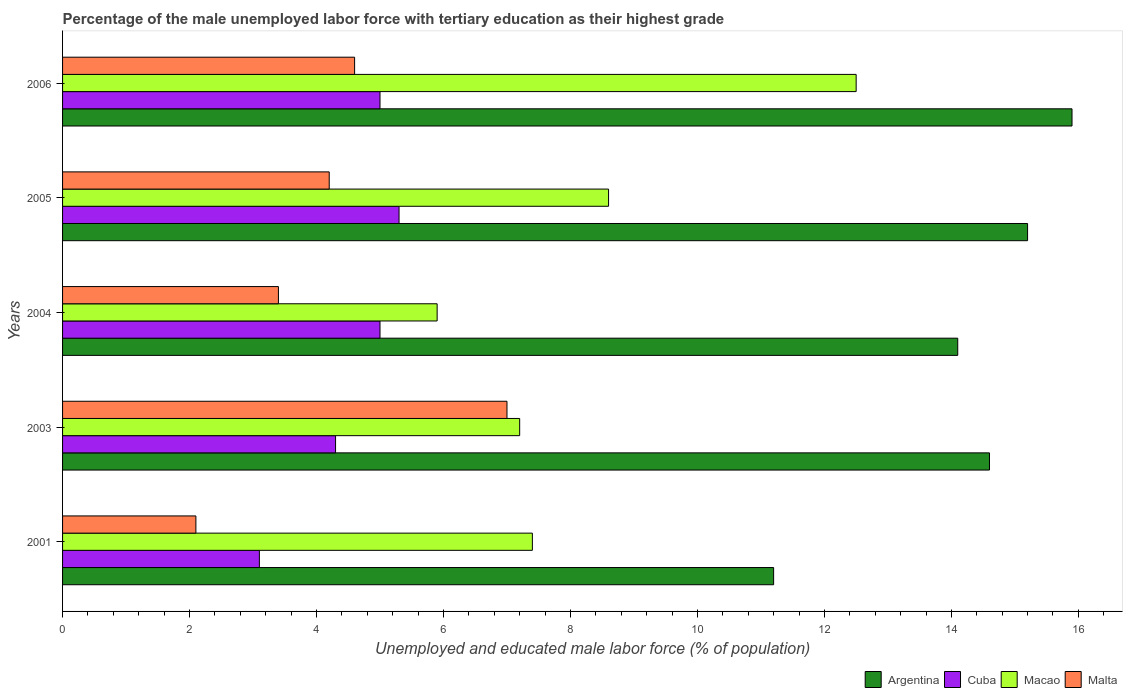How many different coloured bars are there?
Provide a succinct answer. 4. How many groups of bars are there?
Your answer should be very brief. 5. Are the number of bars per tick equal to the number of legend labels?
Make the answer very short. Yes. How many bars are there on the 4th tick from the top?
Provide a succinct answer. 4. How many bars are there on the 3rd tick from the bottom?
Give a very brief answer. 4. What is the percentage of the unemployed male labor force with tertiary education in Cuba in 2001?
Your answer should be very brief. 3.1. Across all years, what is the maximum percentage of the unemployed male labor force with tertiary education in Argentina?
Offer a very short reply. 15.9. Across all years, what is the minimum percentage of the unemployed male labor force with tertiary education in Macao?
Offer a very short reply. 5.9. In which year was the percentage of the unemployed male labor force with tertiary education in Argentina minimum?
Make the answer very short. 2001. What is the total percentage of the unemployed male labor force with tertiary education in Argentina in the graph?
Give a very brief answer. 71. What is the difference between the percentage of the unemployed male labor force with tertiary education in Malta in 2005 and that in 2006?
Make the answer very short. -0.4. What is the difference between the percentage of the unemployed male labor force with tertiary education in Cuba in 2006 and the percentage of the unemployed male labor force with tertiary education in Malta in 2003?
Provide a succinct answer. -2. What is the average percentage of the unemployed male labor force with tertiary education in Argentina per year?
Ensure brevity in your answer.  14.2. In the year 2004, what is the difference between the percentage of the unemployed male labor force with tertiary education in Cuba and percentage of the unemployed male labor force with tertiary education in Argentina?
Give a very brief answer. -9.1. What is the ratio of the percentage of the unemployed male labor force with tertiary education in Cuba in 2003 to that in 2006?
Offer a very short reply. 0.86. Is the difference between the percentage of the unemployed male labor force with tertiary education in Cuba in 2003 and 2004 greater than the difference between the percentage of the unemployed male labor force with tertiary education in Argentina in 2003 and 2004?
Ensure brevity in your answer.  No. What is the difference between the highest and the second highest percentage of the unemployed male labor force with tertiary education in Cuba?
Your answer should be compact. 0.3. What is the difference between the highest and the lowest percentage of the unemployed male labor force with tertiary education in Argentina?
Give a very brief answer. 4.7. What does the 3rd bar from the top in 2001 represents?
Offer a terse response. Cuba. What does the 4th bar from the bottom in 2006 represents?
Provide a short and direct response. Malta. How many bars are there?
Offer a very short reply. 20. Are all the bars in the graph horizontal?
Provide a short and direct response. Yes. What is the difference between two consecutive major ticks on the X-axis?
Your answer should be compact. 2. Does the graph contain any zero values?
Give a very brief answer. No. Where does the legend appear in the graph?
Keep it short and to the point. Bottom right. How many legend labels are there?
Your answer should be compact. 4. What is the title of the graph?
Your answer should be very brief. Percentage of the male unemployed labor force with tertiary education as their highest grade. Does "Bhutan" appear as one of the legend labels in the graph?
Offer a very short reply. No. What is the label or title of the X-axis?
Offer a terse response. Unemployed and educated male labor force (% of population). What is the Unemployed and educated male labor force (% of population) of Argentina in 2001?
Offer a terse response. 11.2. What is the Unemployed and educated male labor force (% of population) in Cuba in 2001?
Give a very brief answer. 3.1. What is the Unemployed and educated male labor force (% of population) of Macao in 2001?
Offer a very short reply. 7.4. What is the Unemployed and educated male labor force (% of population) in Malta in 2001?
Give a very brief answer. 2.1. What is the Unemployed and educated male labor force (% of population) in Argentina in 2003?
Your response must be concise. 14.6. What is the Unemployed and educated male labor force (% of population) of Cuba in 2003?
Provide a succinct answer. 4.3. What is the Unemployed and educated male labor force (% of population) in Macao in 2003?
Provide a short and direct response. 7.2. What is the Unemployed and educated male labor force (% of population) in Malta in 2003?
Make the answer very short. 7. What is the Unemployed and educated male labor force (% of population) of Argentina in 2004?
Keep it short and to the point. 14.1. What is the Unemployed and educated male labor force (% of population) in Macao in 2004?
Offer a terse response. 5.9. What is the Unemployed and educated male labor force (% of population) of Malta in 2004?
Your answer should be very brief. 3.4. What is the Unemployed and educated male labor force (% of population) of Argentina in 2005?
Give a very brief answer. 15.2. What is the Unemployed and educated male labor force (% of population) of Cuba in 2005?
Make the answer very short. 5.3. What is the Unemployed and educated male labor force (% of population) in Macao in 2005?
Keep it short and to the point. 8.6. What is the Unemployed and educated male labor force (% of population) of Malta in 2005?
Give a very brief answer. 4.2. What is the Unemployed and educated male labor force (% of population) in Argentina in 2006?
Your answer should be compact. 15.9. What is the Unemployed and educated male labor force (% of population) in Cuba in 2006?
Your answer should be compact. 5. What is the Unemployed and educated male labor force (% of population) of Malta in 2006?
Provide a short and direct response. 4.6. Across all years, what is the maximum Unemployed and educated male labor force (% of population) in Argentina?
Your answer should be compact. 15.9. Across all years, what is the maximum Unemployed and educated male labor force (% of population) of Cuba?
Provide a succinct answer. 5.3. Across all years, what is the maximum Unemployed and educated male labor force (% of population) in Malta?
Give a very brief answer. 7. Across all years, what is the minimum Unemployed and educated male labor force (% of population) in Argentina?
Your response must be concise. 11.2. Across all years, what is the minimum Unemployed and educated male labor force (% of population) in Cuba?
Ensure brevity in your answer.  3.1. Across all years, what is the minimum Unemployed and educated male labor force (% of population) in Macao?
Provide a short and direct response. 5.9. Across all years, what is the minimum Unemployed and educated male labor force (% of population) of Malta?
Offer a very short reply. 2.1. What is the total Unemployed and educated male labor force (% of population) in Argentina in the graph?
Ensure brevity in your answer.  71. What is the total Unemployed and educated male labor force (% of population) of Cuba in the graph?
Make the answer very short. 22.7. What is the total Unemployed and educated male labor force (% of population) in Macao in the graph?
Your answer should be compact. 41.6. What is the total Unemployed and educated male labor force (% of population) in Malta in the graph?
Provide a short and direct response. 21.3. What is the difference between the Unemployed and educated male labor force (% of population) of Cuba in 2001 and that in 2003?
Provide a succinct answer. -1.2. What is the difference between the Unemployed and educated male labor force (% of population) of Macao in 2001 and that in 2003?
Provide a short and direct response. 0.2. What is the difference between the Unemployed and educated male labor force (% of population) of Malta in 2001 and that in 2003?
Make the answer very short. -4.9. What is the difference between the Unemployed and educated male labor force (% of population) in Argentina in 2001 and that in 2004?
Your answer should be compact. -2.9. What is the difference between the Unemployed and educated male labor force (% of population) in Macao in 2001 and that in 2004?
Provide a short and direct response. 1.5. What is the difference between the Unemployed and educated male labor force (% of population) of Malta in 2001 and that in 2004?
Keep it short and to the point. -1.3. What is the difference between the Unemployed and educated male labor force (% of population) of Cuba in 2001 and that in 2005?
Provide a succinct answer. -2.2. What is the difference between the Unemployed and educated male labor force (% of population) of Macao in 2001 and that in 2005?
Ensure brevity in your answer.  -1.2. What is the difference between the Unemployed and educated male labor force (% of population) of Malta in 2001 and that in 2005?
Provide a short and direct response. -2.1. What is the difference between the Unemployed and educated male labor force (% of population) of Cuba in 2001 and that in 2006?
Your response must be concise. -1.9. What is the difference between the Unemployed and educated male labor force (% of population) of Macao in 2001 and that in 2006?
Ensure brevity in your answer.  -5.1. What is the difference between the Unemployed and educated male labor force (% of population) of Argentina in 2003 and that in 2004?
Give a very brief answer. 0.5. What is the difference between the Unemployed and educated male labor force (% of population) in Cuba in 2003 and that in 2004?
Offer a terse response. -0.7. What is the difference between the Unemployed and educated male labor force (% of population) in Macao in 2003 and that in 2005?
Give a very brief answer. -1.4. What is the difference between the Unemployed and educated male labor force (% of population) of Argentina in 2004 and that in 2005?
Make the answer very short. -1.1. What is the difference between the Unemployed and educated male labor force (% of population) in Macao in 2004 and that in 2005?
Give a very brief answer. -2.7. What is the difference between the Unemployed and educated male labor force (% of population) in Malta in 2004 and that in 2005?
Your answer should be very brief. -0.8. What is the difference between the Unemployed and educated male labor force (% of population) in Argentina in 2004 and that in 2006?
Offer a very short reply. -1.8. What is the difference between the Unemployed and educated male labor force (% of population) of Cuba in 2004 and that in 2006?
Give a very brief answer. 0. What is the difference between the Unemployed and educated male labor force (% of population) of Macao in 2004 and that in 2006?
Your answer should be very brief. -6.6. What is the difference between the Unemployed and educated male labor force (% of population) in Cuba in 2005 and that in 2006?
Make the answer very short. 0.3. What is the difference between the Unemployed and educated male labor force (% of population) of Malta in 2005 and that in 2006?
Give a very brief answer. -0.4. What is the difference between the Unemployed and educated male labor force (% of population) in Argentina in 2001 and the Unemployed and educated male labor force (% of population) in Macao in 2003?
Offer a very short reply. 4. What is the difference between the Unemployed and educated male labor force (% of population) in Cuba in 2001 and the Unemployed and educated male labor force (% of population) in Macao in 2003?
Your response must be concise. -4.1. What is the difference between the Unemployed and educated male labor force (% of population) of Cuba in 2001 and the Unemployed and educated male labor force (% of population) of Malta in 2003?
Offer a very short reply. -3.9. What is the difference between the Unemployed and educated male labor force (% of population) of Macao in 2001 and the Unemployed and educated male labor force (% of population) of Malta in 2003?
Keep it short and to the point. 0.4. What is the difference between the Unemployed and educated male labor force (% of population) of Argentina in 2001 and the Unemployed and educated male labor force (% of population) of Cuba in 2004?
Ensure brevity in your answer.  6.2. What is the difference between the Unemployed and educated male labor force (% of population) in Argentina in 2001 and the Unemployed and educated male labor force (% of population) in Macao in 2004?
Make the answer very short. 5.3. What is the difference between the Unemployed and educated male labor force (% of population) of Cuba in 2001 and the Unemployed and educated male labor force (% of population) of Malta in 2004?
Offer a very short reply. -0.3. What is the difference between the Unemployed and educated male labor force (% of population) of Macao in 2001 and the Unemployed and educated male labor force (% of population) of Malta in 2004?
Provide a succinct answer. 4. What is the difference between the Unemployed and educated male labor force (% of population) in Argentina in 2001 and the Unemployed and educated male labor force (% of population) in Malta in 2005?
Give a very brief answer. 7. What is the difference between the Unemployed and educated male labor force (% of population) in Cuba in 2001 and the Unemployed and educated male labor force (% of population) in Macao in 2005?
Offer a terse response. -5.5. What is the difference between the Unemployed and educated male labor force (% of population) in Cuba in 2001 and the Unemployed and educated male labor force (% of population) in Malta in 2005?
Offer a very short reply. -1.1. What is the difference between the Unemployed and educated male labor force (% of population) of Argentina in 2001 and the Unemployed and educated male labor force (% of population) of Macao in 2006?
Offer a very short reply. -1.3. What is the difference between the Unemployed and educated male labor force (% of population) in Cuba in 2001 and the Unemployed and educated male labor force (% of population) in Malta in 2006?
Provide a succinct answer. -1.5. What is the difference between the Unemployed and educated male labor force (% of population) in Argentina in 2003 and the Unemployed and educated male labor force (% of population) in Cuba in 2004?
Provide a short and direct response. 9.6. What is the difference between the Unemployed and educated male labor force (% of population) in Argentina in 2003 and the Unemployed and educated male labor force (% of population) in Macao in 2004?
Provide a succinct answer. 8.7. What is the difference between the Unemployed and educated male labor force (% of population) of Argentina in 2003 and the Unemployed and educated male labor force (% of population) of Malta in 2004?
Ensure brevity in your answer.  11.2. What is the difference between the Unemployed and educated male labor force (% of population) in Cuba in 2003 and the Unemployed and educated male labor force (% of population) in Macao in 2004?
Provide a short and direct response. -1.6. What is the difference between the Unemployed and educated male labor force (% of population) of Macao in 2003 and the Unemployed and educated male labor force (% of population) of Malta in 2004?
Your response must be concise. 3.8. What is the difference between the Unemployed and educated male labor force (% of population) in Argentina in 2003 and the Unemployed and educated male labor force (% of population) in Cuba in 2005?
Your answer should be very brief. 9.3. What is the difference between the Unemployed and educated male labor force (% of population) in Argentina in 2003 and the Unemployed and educated male labor force (% of population) in Malta in 2005?
Your response must be concise. 10.4. What is the difference between the Unemployed and educated male labor force (% of population) in Cuba in 2003 and the Unemployed and educated male labor force (% of population) in Macao in 2005?
Provide a short and direct response. -4.3. What is the difference between the Unemployed and educated male labor force (% of population) of Cuba in 2003 and the Unemployed and educated male labor force (% of population) of Malta in 2005?
Keep it short and to the point. 0.1. What is the difference between the Unemployed and educated male labor force (% of population) in Argentina in 2003 and the Unemployed and educated male labor force (% of population) in Macao in 2006?
Keep it short and to the point. 2.1. What is the difference between the Unemployed and educated male labor force (% of population) of Cuba in 2003 and the Unemployed and educated male labor force (% of population) of Macao in 2006?
Offer a terse response. -8.2. What is the difference between the Unemployed and educated male labor force (% of population) in Macao in 2003 and the Unemployed and educated male labor force (% of population) in Malta in 2006?
Your answer should be compact. 2.6. What is the difference between the Unemployed and educated male labor force (% of population) of Argentina in 2004 and the Unemployed and educated male labor force (% of population) of Macao in 2005?
Make the answer very short. 5.5. What is the difference between the Unemployed and educated male labor force (% of population) in Argentina in 2004 and the Unemployed and educated male labor force (% of population) in Malta in 2005?
Give a very brief answer. 9.9. What is the difference between the Unemployed and educated male labor force (% of population) of Macao in 2004 and the Unemployed and educated male labor force (% of population) of Malta in 2005?
Your answer should be compact. 1.7. What is the difference between the Unemployed and educated male labor force (% of population) of Argentina in 2004 and the Unemployed and educated male labor force (% of population) of Cuba in 2006?
Provide a succinct answer. 9.1. What is the difference between the Unemployed and educated male labor force (% of population) of Argentina in 2004 and the Unemployed and educated male labor force (% of population) of Malta in 2006?
Provide a succinct answer. 9.5. What is the difference between the Unemployed and educated male labor force (% of population) of Macao in 2004 and the Unemployed and educated male labor force (% of population) of Malta in 2006?
Ensure brevity in your answer.  1.3. What is the difference between the Unemployed and educated male labor force (% of population) of Argentina in 2005 and the Unemployed and educated male labor force (% of population) of Macao in 2006?
Ensure brevity in your answer.  2.7. What is the difference between the Unemployed and educated male labor force (% of population) of Argentina in 2005 and the Unemployed and educated male labor force (% of population) of Malta in 2006?
Give a very brief answer. 10.6. What is the difference between the Unemployed and educated male labor force (% of population) in Cuba in 2005 and the Unemployed and educated male labor force (% of population) in Macao in 2006?
Make the answer very short. -7.2. What is the average Unemployed and educated male labor force (% of population) of Cuba per year?
Make the answer very short. 4.54. What is the average Unemployed and educated male labor force (% of population) of Macao per year?
Offer a terse response. 8.32. What is the average Unemployed and educated male labor force (% of population) in Malta per year?
Offer a terse response. 4.26. In the year 2001, what is the difference between the Unemployed and educated male labor force (% of population) in Argentina and Unemployed and educated male labor force (% of population) in Cuba?
Give a very brief answer. 8.1. In the year 2003, what is the difference between the Unemployed and educated male labor force (% of population) in Argentina and Unemployed and educated male labor force (% of population) in Cuba?
Provide a short and direct response. 10.3. In the year 2003, what is the difference between the Unemployed and educated male labor force (% of population) in Cuba and Unemployed and educated male labor force (% of population) in Malta?
Give a very brief answer. -2.7. In the year 2003, what is the difference between the Unemployed and educated male labor force (% of population) in Macao and Unemployed and educated male labor force (% of population) in Malta?
Your response must be concise. 0.2. In the year 2004, what is the difference between the Unemployed and educated male labor force (% of population) in Argentina and Unemployed and educated male labor force (% of population) in Macao?
Make the answer very short. 8.2. In the year 2004, what is the difference between the Unemployed and educated male labor force (% of population) in Argentina and Unemployed and educated male labor force (% of population) in Malta?
Make the answer very short. 10.7. In the year 2004, what is the difference between the Unemployed and educated male labor force (% of population) of Cuba and Unemployed and educated male labor force (% of population) of Malta?
Your response must be concise. 1.6. In the year 2005, what is the difference between the Unemployed and educated male labor force (% of population) of Argentina and Unemployed and educated male labor force (% of population) of Cuba?
Give a very brief answer. 9.9. In the year 2005, what is the difference between the Unemployed and educated male labor force (% of population) in Cuba and Unemployed and educated male labor force (% of population) in Macao?
Make the answer very short. -3.3. In the year 2005, what is the difference between the Unemployed and educated male labor force (% of population) in Cuba and Unemployed and educated male labor force (% of population) in Malta?
Provide a succinct answer. 1.1. In the year 2005, what is the difference between the Unemployed and educated male labor force (% of population) of Macao and Unemployed and educated male labor force (% of population) of Malta?
Keep it short and to the point. 4.4. In the year 2006, what is the difference between the Unemployed and educated male labor force (% of population) of Argentina and Unemployed and educated male labor force (% of population) of Cuba?
Provide a short and direct response. 10.9. In the year 2006, what is the difference between the Unemployed and educated male labor force (% of population) in Argentina and Unemployed and educated male labor force (% of population) in Malta?
Your answer should be compact. 11.3. In the year 2006, what is the difference between the Unemployed and educated male labor force (% of population) of Cuba and Unemployed and educated male labor force (% of population) of Malta?
Offer a terse response. 0.4. What is the ratio of the Unemployed and educated male labor force (% of population) of Argentina in 2001 to that in 2003?
Your answer should be very brief. 0.77. What is the ratio of the Unemployed and educated male labor force (% of population) in Cuba in 2001 to that in 2003?
Make the answer very short. 0.72. What is the ratio of the Unemployed and educated male labor force (% of population) in Macao in 2001 to that in 2003?
Give a very brief answer. 1.03. What is the ratio of the Unemployed and educated male labor force (% of population) in Argentina in 2001 to that in 2004?
Your answer should be very brief. 0.79. What is the ratio of the Unemployed and educated male labor force (% of population) of Cuba in 2001 to that in 2004?
Give a very brief answer. 0.62. What is the ratio of the Unemployed and educated male labor force (% of population) in Macao in 2001 to that in 2004?
Give a very brief answer. 1.25. What is the ratio of the Unemployed and educated male labor force (% of population) of Malta in 2001 to that in 2004?
Your answer should be compact. 0.62. What is the ratio of the Unemployed and educated male labor force (% of population) in Argentina in 2001 to that in 2005?
Keep it short and to the point. 0.74. What is the ratio of the Unemployed and educated male labor force (% of population) in Cuba in 2001 to that in 2005?
Provide a succinct answer. 0.58. What is the ratio of the Unemployed and educated male labor force (% of population) in Macao in 2001 to that in 2005?
Provide a short and direct response. 0.86. What is the ratio of the Unemployed and educated male labor force (% of population) in Argentina in 2001 to that in 2006?
Your response must be concise. 0.7. What is the ratio of the Unemployed and educated male labor force (% of population) of Cuba in 2001 to that in 2006?
Your response must be concise. 0.62. What is the ratio of the Unemployed and educated male labor force (% of population) in Macao in 2001 to that in 2006?
Your answer should be very brief. 0.59. What is the ratio of the Unemployed and educated male labor force (% of population) in Malta in 2001 to that in 2006?
Make the answer very short. 0.46. What is the ratio of the Unemployed and educated male labor force (% of population) in Argentina in 2003 to that in 2004?
Provide a short and direct response. 1.04. What is the ratio of the Unemployed and educated male labor force (% of population) in Cuba in 2003 to that in 2004?
Offer a very short reply. 0.86. What is the ratio of the Unemployed and educated male labor force (% of population) in Macao in 2003 to that in 2004?
Offer a very short reply. 1.22. What is the ratio of the Unemployed and educated male labor force (% of population) of Malta in 2003 to that in 2004?
Offer a terse response. 2.06. What is the ratio of the Unemployed and educated male labor force (% of population) in Argentina in 2003 to that in 2005?
Your answer should be very brief. 0.96. What is the ratio of the Unemployed and educated male labor force (% of population) of Cuba in 2003 to that in 2005?
Give a very brief answer. 0.81. What is the ratio of the Unemployed and educated male labor force (% of population) of Macao in 2003 to that in 2005?
Your response must be concise. 0.84. What is the ratio of the Unemployed and educated male labor force (% of population) in Malta in 2003 to that in 2005?
Offer a very short reply. 1.67. What is the ratio of the Unemployed and educated male labor force (% of population) in Argentina in 2003 to that in 2006?
Provide a short and direct response. 0.92. What is the ratio of the Unemployed and educated male labor force (% of population) of Cuba in 2003 to that in 2006?
Offer a very short reply. 0.86. What is the ratio of the Unemployed and educated male labor force (% of population) of Macao in 2003 to that in 2006?
Your response must be concise. 0.58. What is the ratio of the Unemployed and educated male labor force (% of population) of Malta in 2003 to that in 2006?
Provide a succinct answer. 1.52. What is the ratio of the Unemployed and educated male labor force (% of population) in Argentina in 2004 to that in 2005?
Offer a terse response. 0.93. What is the ratio of the Unemployed and educated male labor force (% of population) in Cuba in 2004 to that in 2005?
Give a very brief answer. 0.94. What is the ratio of the Unemployed and educated male labor force (% of population) in Macao in 2004 to that in 2005?
Offer a terse response. 0.69. What is the ratio of the Unemployed and educated male labor force (% of population) in Malta in 2004 to that in 2005?
Your answer should be compact. 0.81. What is the ratio of the Unemployed and educated male labor force (% of population) in Argentina in 2004 to that in 2006?
Keep it short and to the point. 0.89. What is the ratio of the Unemployed and educated male labor force (% of population) in Macao in 2004 to that in 2006?
Your answer should be very brief. 0.47. What is the ratio of the Unemployed and educated male labor force (% of population) of Malta in 2004 to that in 2006?
Offer a terse response. 0.74. What is the ratio of the Unemployed and educated male labor force (% of population) in Argentina in 2005 to that in 2006?
Make the answer very short. 0.96. What is the ratio of the Unemployed and educated male labor force (% of population) of Cuba in 2005 to that in 2006?
Keep it short and to the point. 1.06. What is the ratio of the Unemployed and educated male labor force (% of population) in Macao in 2005 to that in 2006?
Ensure brevity in your answer.  0.69. What is the difference between the highest and the second highest Unemployed and educated male labor force (% of population) of Argentina?
Your answer should be compact. 0.7. What is the difference between the highest and the lowest Unemployed and educated male labor force (% of population) of Cuba?
Your answer should be compact. 2.2. What is the difference between the highest and the lowest Unemployed and educated male labor force (% of population) in Macao?
Offer a terse response. 6.6. What is the difference between the highest and the lowest Unemployed and educated male labor force (% of population) in Malta?
Your answer should be very brief. 4.9. 